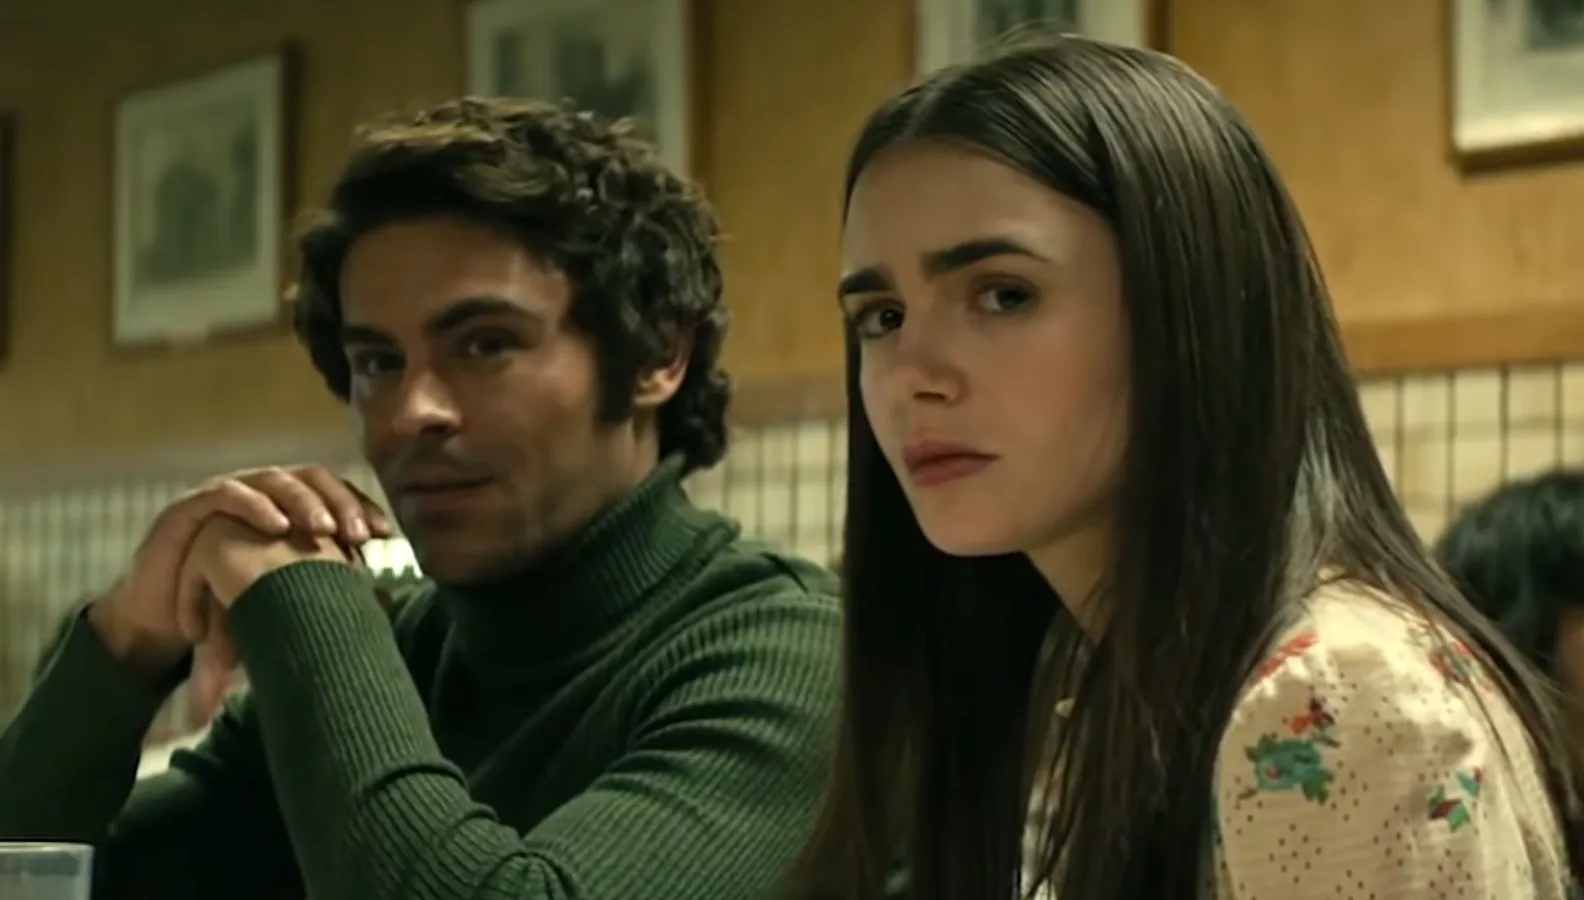Describe the setting and atmosphere of the diner in detail. The diner is a cozy, vintage-style eatery adorned with wooden paneling and framed pictures on the walls, portraying nostalgic scenes that add to its charm. The booth where the actors are seated is upholstered in a classic checkered pattern, complementing the tiled backsplash behind them. The muted tones and soft lighting create a warm, inviting atmosphere, despite the serious mood between the characters. The hum of quiet conversations and the clinking of cutlery fill the air, contributing to the bustling yet intimate ambiance of this charming locale. 